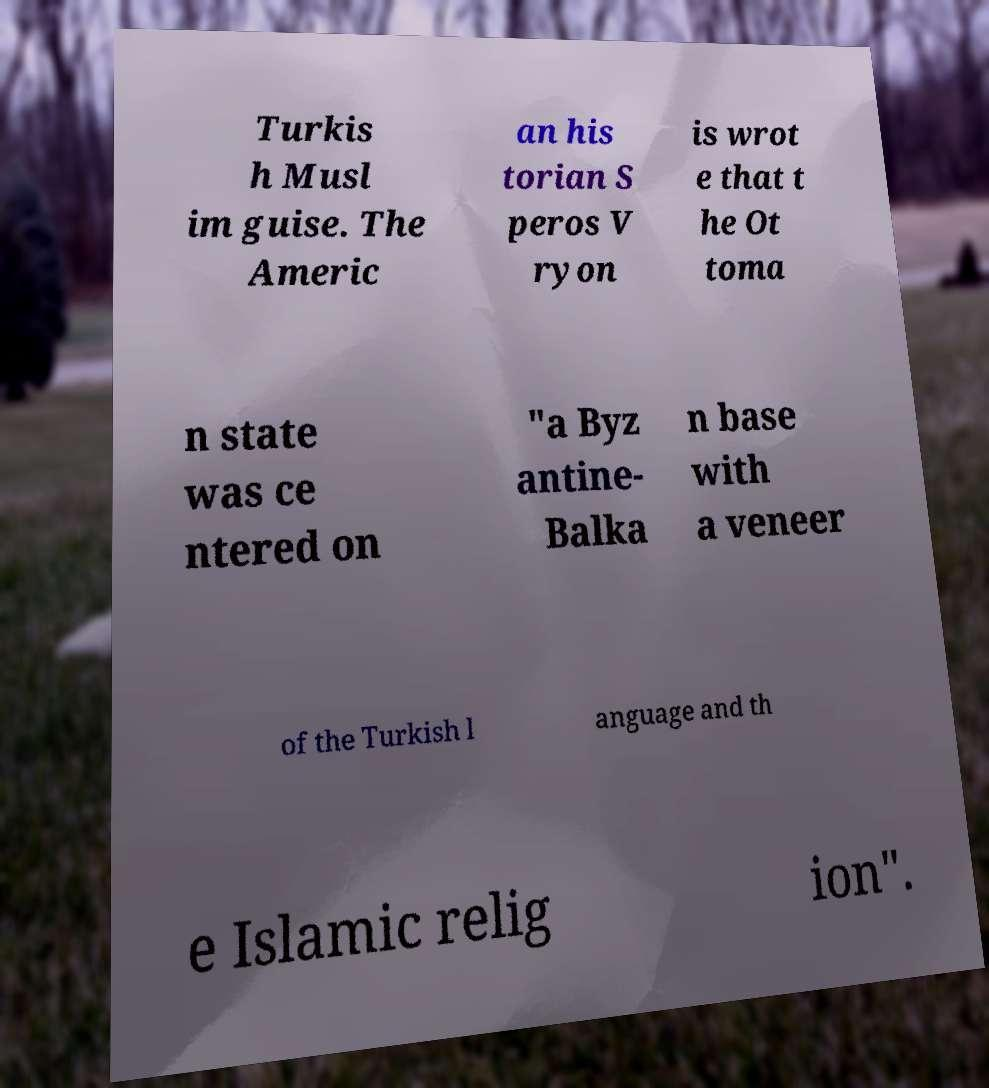There's text embedded in this image that I need extracted. Can you transcribe it verbatim? Turkis h Musl im guise. The Americ an his torian S peros V ryon is wrot e that t he Ot toma n state was ce ntered on "a Byz antine- Balka n base with a veneer of the Turkish l anguage and th e Islamic relig ion". 